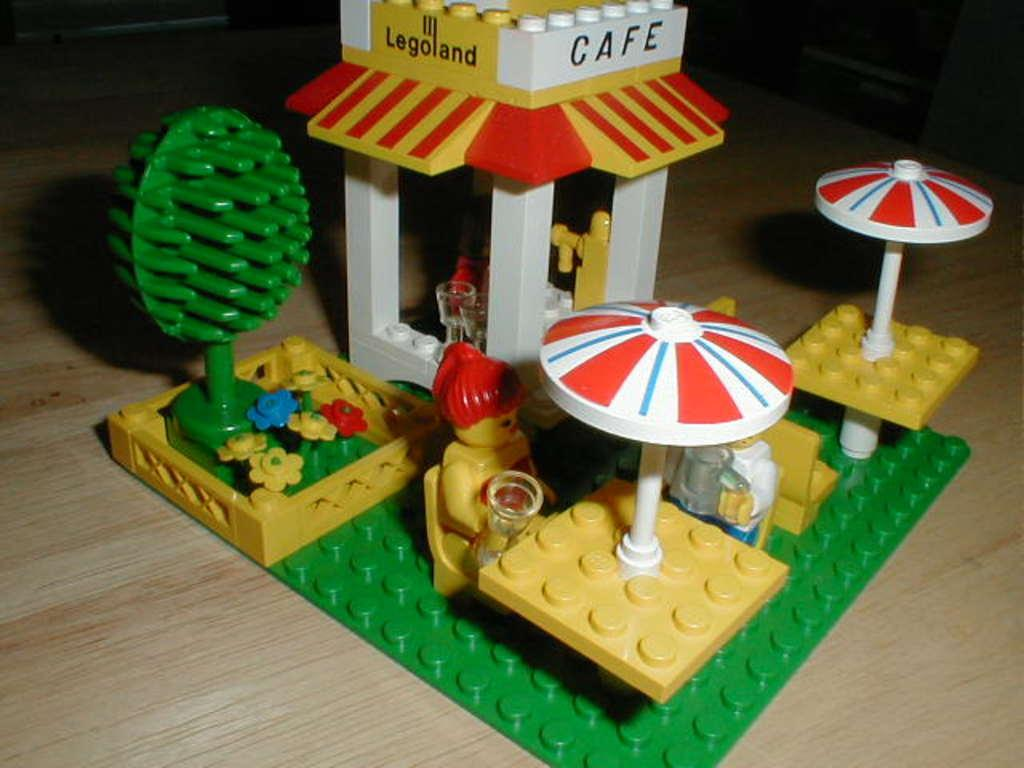What type of toys are in the image? There are Lego toys in the image. Where are the Lego toys located? The Lego toys are on a table. How many pets are visible in the image? There are no pets visible in the image; it only features Lego toys on a table. 